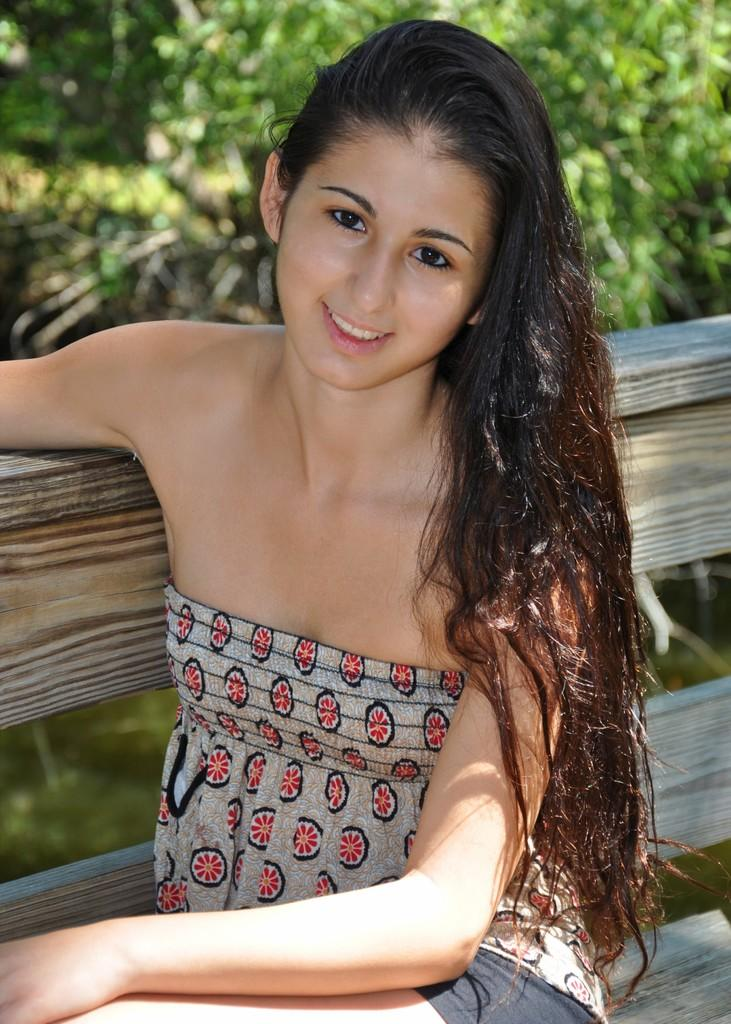Who is the main subject in the image? There is a lady in the image. What is the lady sitting on? The lady is sitting on a wooden bench. What can be seen behind the lady? There are plants behind the lady. How would you describe the background of the image? The background of the image is blurred. What type of goat is standing next to the lady in the image? There is no goat present in the image; the lady is sitting alone on the wooden bench. 